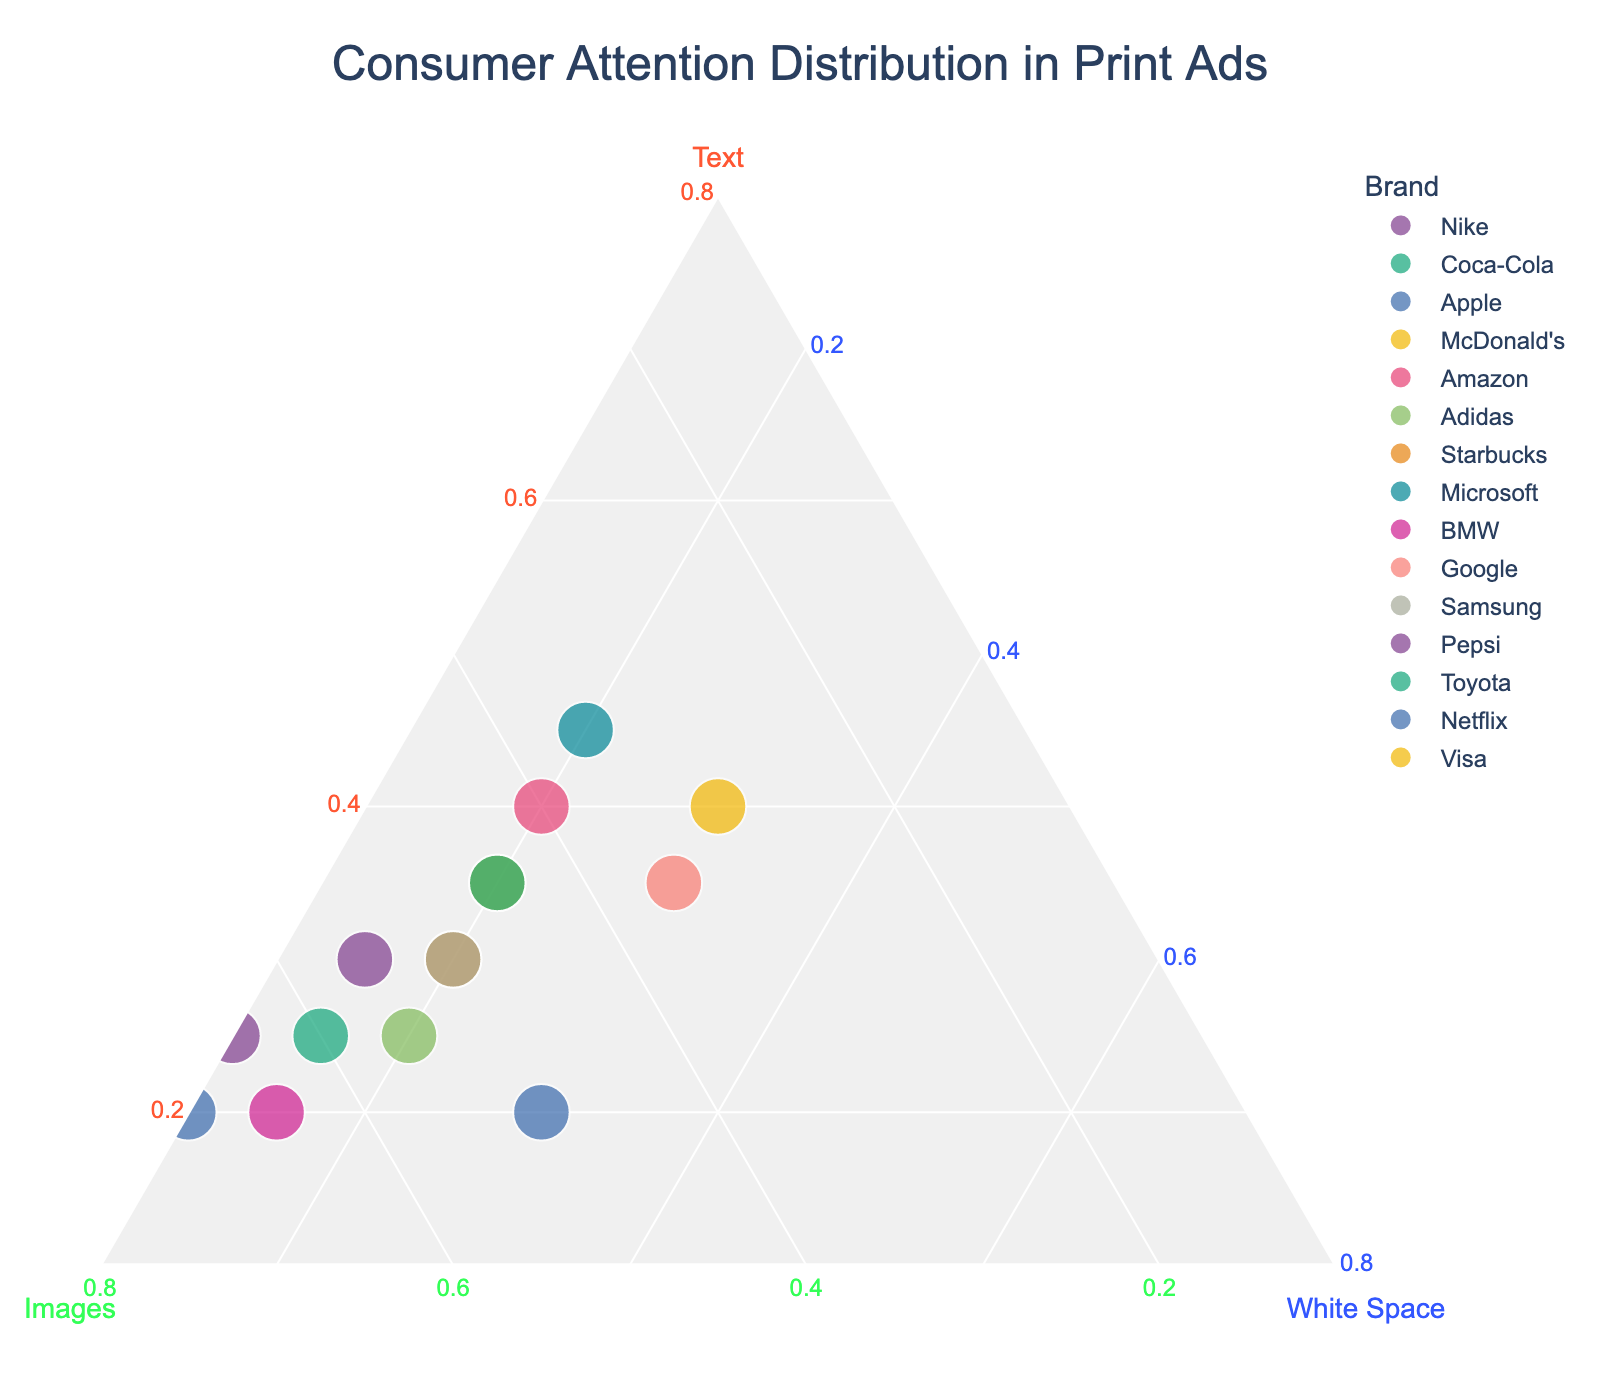what is the title of the plot? The title of the plot is clearly indicated at the top of the figure. It helps viewers understand what the plot represents.
Answer: Consumer Attention Distribution in Print Ads what brand has the highest proportion of images? To find the brand with the highest proportion of images, look for which data point has the highest value along the "Images" axis.
Answer: Netflix which two brands have an equal distribution of white space? Identifying the two brands with the same white space distribution requires finding data points on the "White Space" axis that have the same value.
Answer: Apple and Google is there any brand with an equal distribution of text, images, and white space? Check the plot for any data points that are equidistant from all three vertices of the ternary plot, indicating equal distribution.
Answer: No which brand has more text compared to both images and white space? Locate the brand closest to the "Text" axis vertex of the ternary plot, indicating a higher proportion of text.
Answer: Microsoft which brands distribute consumer attention equally between text and white space? Find the brands where the ratios of "Text" and "White Space" are approximately equal by visual inspection of the plot.
Answer: Apple and Google how many brands are represented in the plot? Count the total data points or the number of unique brands displayed on the ternary plot.
Answer: 15 what is the average proportion of text across all brands? Sum the proportions of text for all brands and divide by the number of brands.
Answer: 30% which brand has the closest attention distribution between text and images? Find the brand where the proportions of text and images are closest by comparing distances from the respective axes.
Answer: Amazon which brand has the smallest proportion of white space? Identify the data point closest to the "White Space" vertex to find the brand with the smallest white space proportion.
Answer: Pepsi 